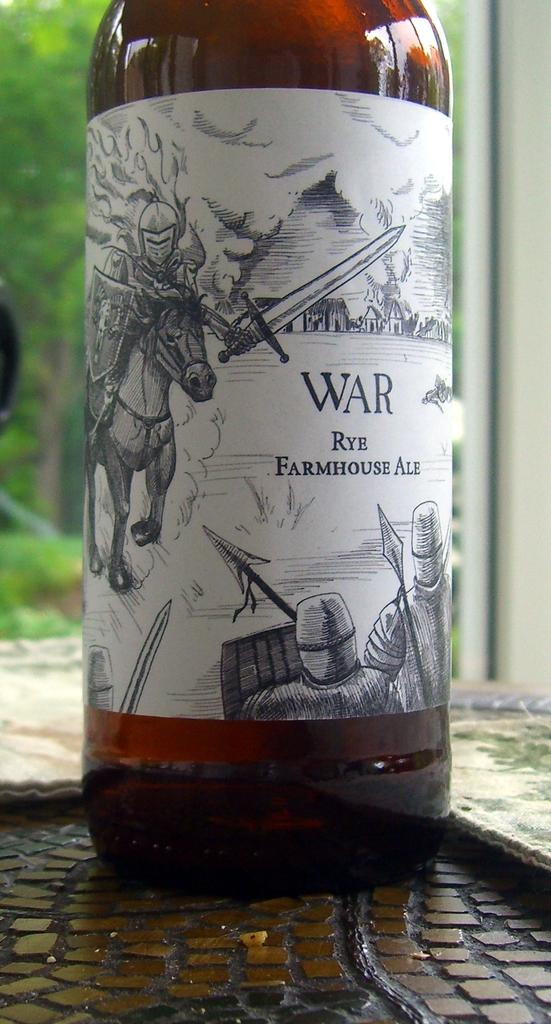<image>
Create a compact narrative representing the image presented. a bottle of ale that is labeled 'war rye farmhouse ale' 